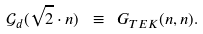<formula> <loc_0><loc_0><loc_500><loc_500>\mathcal { G } _ { d } ( \sqrt { 2 } \cdot n ) \ \equiv \ G _ { T E K } ( n , n ) .</formula> 